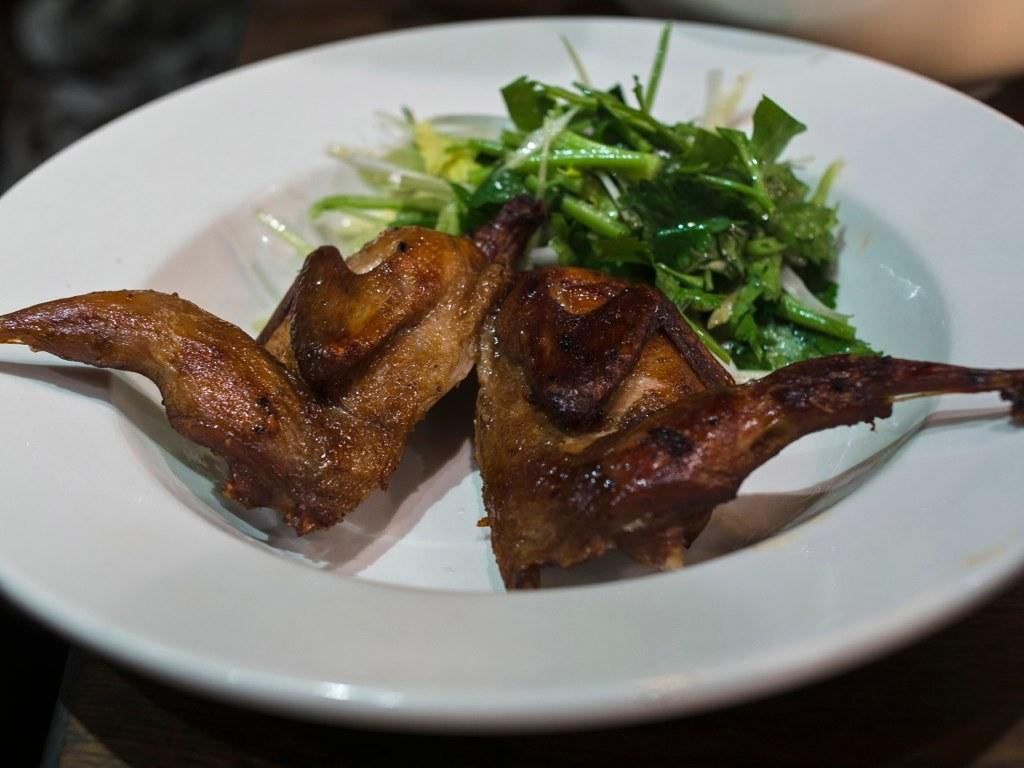What is on the plate that is visible in the image? There is food on a plate in the image. Where is the plate located in the image? The plate is placed on a table. What type of liquid can be seen changing the color of the food in the image? There is no liquid present in the image, and the food does not change color. 